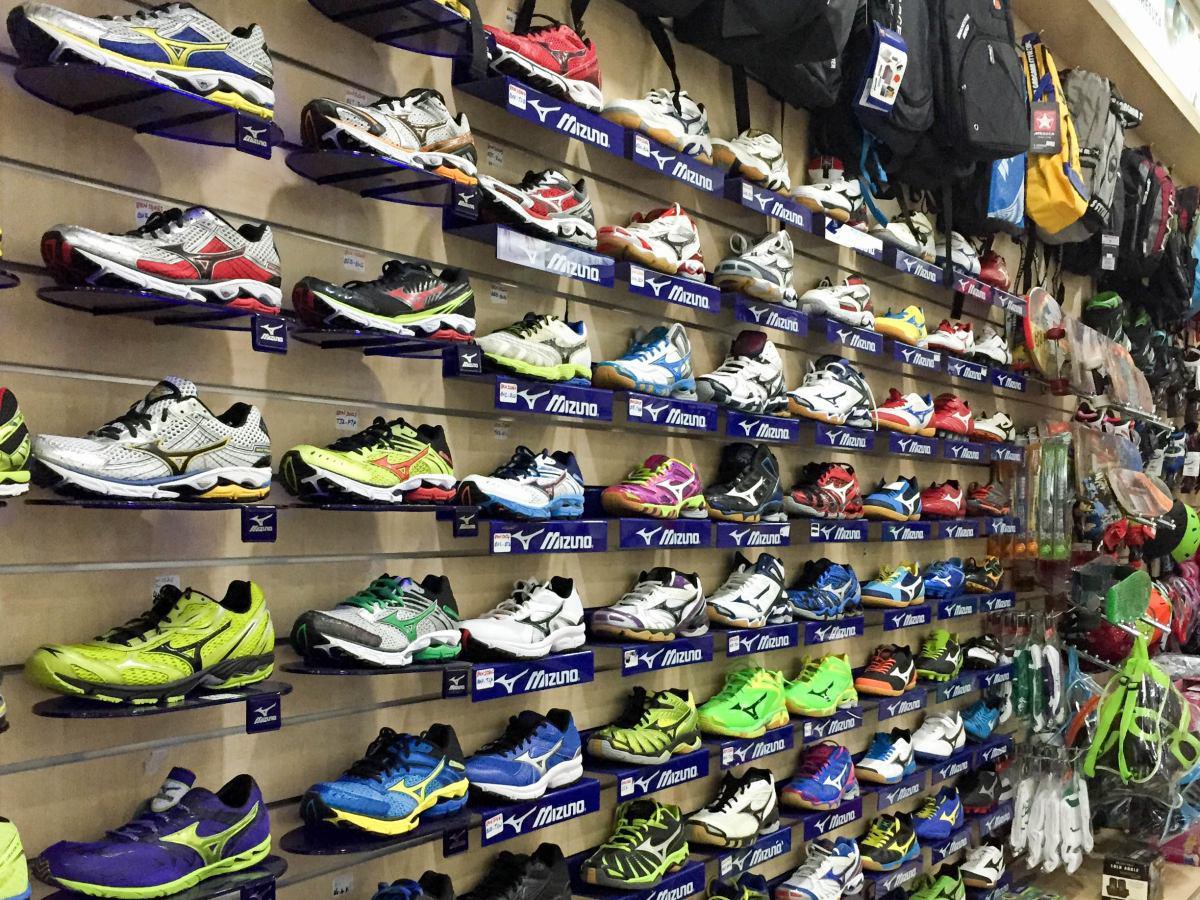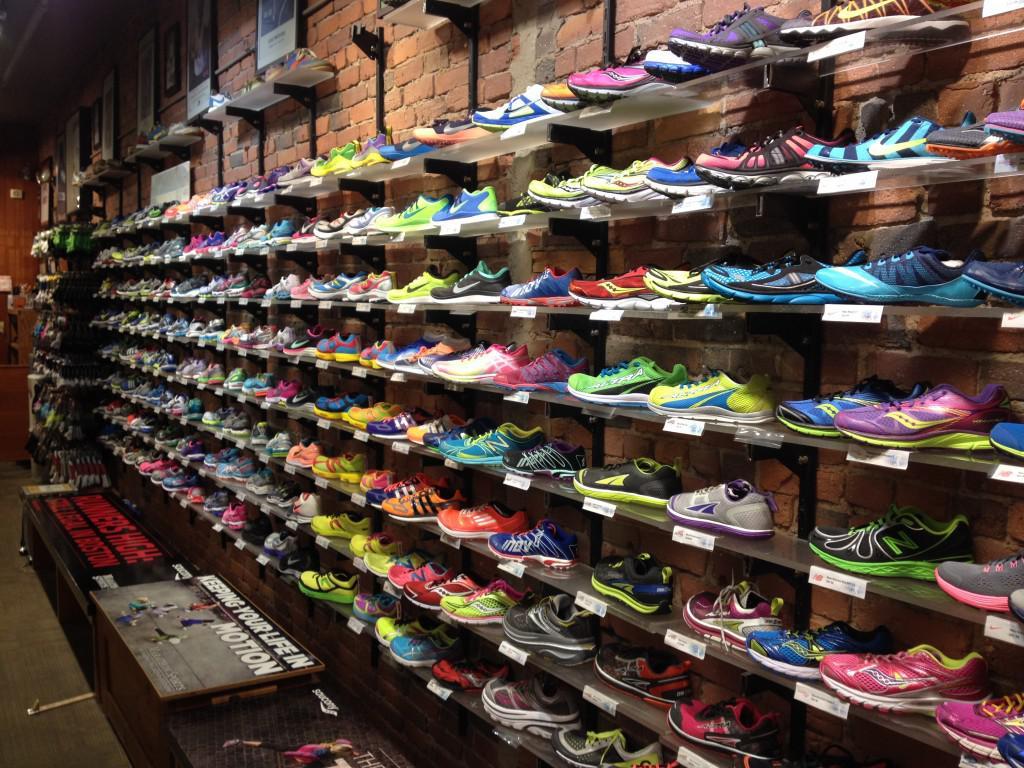The first image is the image on the left, the second image is the image on the right. For the images displayed, is the sentence "The shoes in one of the images are not sitting on the store racks." factually correct? Answer yes or no. No. The first image is the image on the left, the second image is the image on the right. For the images displayed, is the sentence "One image has less than sixteen shoes present." factually correct? Answer yes or no. No. The first image is the image on the left, the second image is the image on the right. For the images displayed, is the sentence "One image shows different sneakers which are not displayed in rows on shelves." factually correct? Answer yes or no. No. 